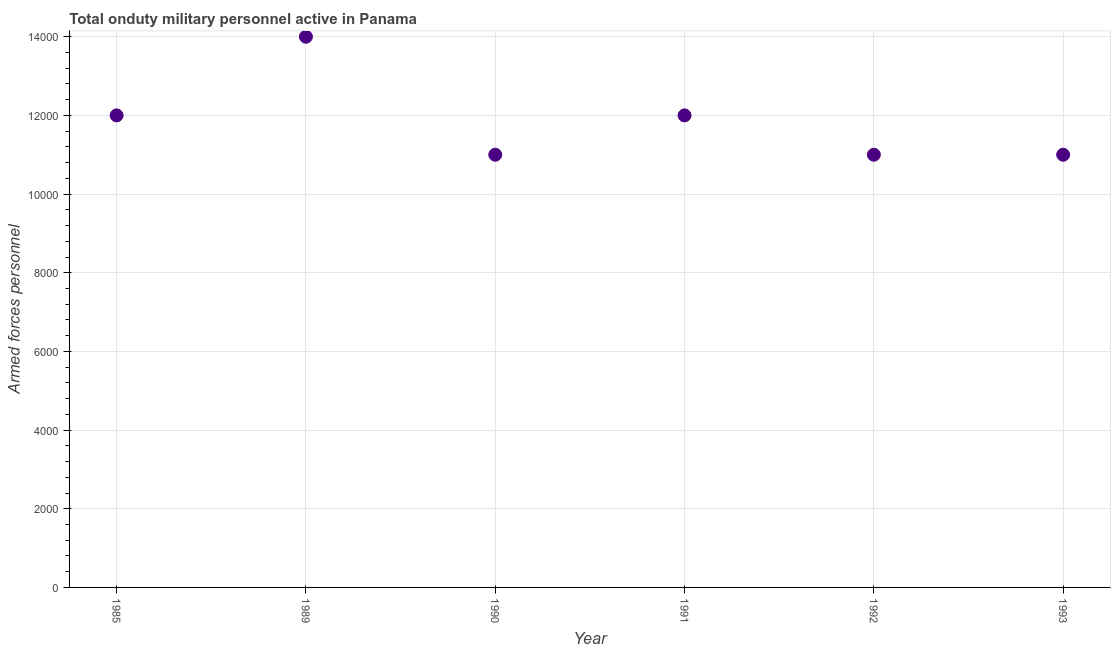What is the number of armed forces personnel in 1991?
Your response must be concise. 1.20e+04. Across all years, what is the maximum number of armed forces personnel?
Provide a succinct answer. 1.40e+04. Across all years, what is the minimum number of armed forces personnel?
Make the answer very short. 1.10e+04. In which year was the number of armed forces personnel maximum?
Offer a terse response. 1989. What is the sum of the number of armed forces personnel?
Your answer should be compact. 7.10e+04. What is the difference between the number of armed forces personnel in 1990 and 1991?
Give a very brief answer. -1000. What is the average number of armed forces personnel per year?
Your response must be concise. 1.18e+04. What is the median number of armed forces personnel?
Provide a succinct answer. 1.15e+04. Do a majority of the years between 1993 and 1991 (inclusive) have number of armed forces personnel greater than 13600 ?
Offer a very short reply. No. What is the ratio of the number of armed forces personnel in 1985 to that in 1989?
Provide a succinct answer. 0.86. What is the difference between the highest and the second highest number of armed forces personnel?
Offer a very short reply. 2000. What is the difference between the highest and the lowest number of armed forces personnel?
Keep it short and to the point. 3000. In how many years, is the number of armed forces personnel greater than the average number of armed forces personnel taken over all years?
Your answer should be very brief. 3. Does the number of armed forces personnel monotonically increase over the years?
Offer a very short reply. No. How many years are there in the graph?
Your answer should be very brief. 6. What is the difference between two consecutive major ticks on the Y-axis?
Provide a succinct answer. 2000. Are the values on the major ticks of Y-axis written in scientific E-notation?
Make the answer very short. No. Does the graph contain any zero values?
Offer a terse response. No. What is the title of the graph?
Ensure brevity in your answer.  Total onduty military personnel active in Panama. What is the label or title of the X-axis?
Your response must be concise. Year. What is the label or title of the Y-axis?
Your answer should be very brief. Armed forces personnel. What is the Armed forces personnel in 1985?
Give a very brief answer. 1.20e+04. What is the Armed forces personnel in 1989?
Keep it short and to the point. 1.40e+04. What is the Armed forces personnel in 1990?
Your answer should be compact. 1.10e+04. What is the Armed forces personnel in 1991?
Keep it short and to the point. 1.20e+04. What is the Armed forces personnel in 1992?
Provide a short and direct response. 1.10e+04. What is the Armed forces personnel in 1993?
Give a very brief answer. 1.10e+04. What is the difference between the Armed forces personnel in 1985 and 1989?
Provide a short and direct response. -2000. What is the difference between the Armed forces personnel in 1985 and 1990?
Your answer should be very brief. 1000. What is the difference between the Armed forces personnel in 1985 and 1991?
Your answer should be compact. 0. What is the difference between the Armed forces personnel in 1985 and 1993?
Provide a short and direct response. 1000. What is the difference between the Armed forces personnel in 1989 and 1990?
Make the answer very short. 3000. What is the difference between the Armed forces personnel in 1989 and 1991?
Provide a short and direct response. 2000. What is the difference between the Armed forces personnel in 1989 and 1992?
Keep it short and to the point. 3000. What is the difference between the Armed forces personnel in 1989 and 1993?
Ensure brevity in your answer.  3000. What is the difference between the Armed forces personnel in 1990 and 1991?
Keep it short and to the point. -1000. What is the difference between the Armed forces personnel in 1990 and 1993?
Ensure brevity in your answer.  0. What is the difference between the Armed forces personnel in 1991 and 1992?
Provide a succinct answer. 1000. What is the difference between the Armed forces personnel in 1992 and 1993?
Offer a terse response. 0. What is the ratio of the Armed forces personnel in 1985 to that in 1989?
Your response must be concise. 0.86. What is the ratio of the Armed forces personnel in 1985 to that in 1990?
Ensure brevity in your answer.  1.09. What is the ratio of the Armed forces personnel in 1985 to that in 1991?
Keep it short and to the point. 1. What is the ratio of the Armed forces personnel in 1985 to that in 1992?
Give a very brief answer. 1.09. What is the ratio of the Armed forces personnel in 1985 to that in 1993?
Your answer should be compact. 1.09. What is the ratio of the Armed forces personnel in 1989 to that in 1990?
Offer a very short reply. 1.27. What is the ratio of the Armed forces personnel in 1989 to that in 1991?
Provide a short and direct response. 1.17. What is the ratio of the Armed forces personnel in 1989 to that in 1992?
Make the answer very short. 1.27. What is the ratio of the Armed forces personnel in 1989 to that in 1993?
Your answer should be very brief. 1.27. What is the ratio of the Armed forces personnel in 1990 to that in 1991?
Provide a short and direct response. 0.92. What is the ratio of the Armed forces personnel in 1990 to that in 1993?
Your response must be concise. 1. What is the ratio of the Armed forces personnel in 1991 to that in 1992?
Your answer should be very brief. 1.09. What is the ratio of the Armed forces personnel in 1991 to that in 1993?
Your answer should be compact. 1.09. 